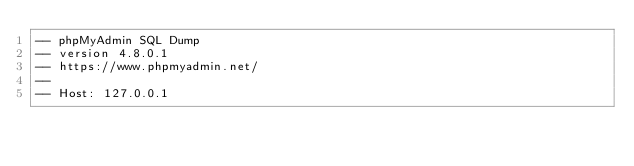Convert code to text. <code><loc_0><loc_0><loc_500><loc_500><_SQL_>-- phpMyAdmin SQL Dump
-- version 4.8.0.1
-- https://www.phpmyadmin.net/
--
-- Host: 127.0.0.1</code> 